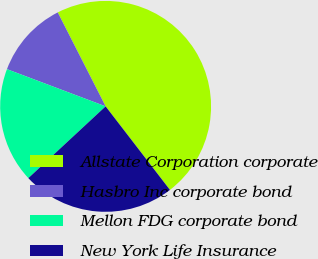Convert chart to OTSL. <chart><loc_0><loc_0><loc_500><loc_500><pie_chart><fcel>Allstate Corporation corporate<fcel>Hasbro Inc corporate bond<fcel>Mellon FDG corporate bond<fcel>New York Life Insurance<nl><fcel>47.06%<fcel>11.76%<fcel>17.65%<fcel>23.53%<nl></chart> 